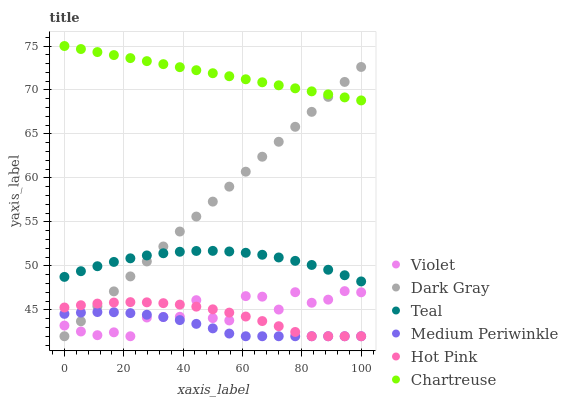Does Medium Periwinkle have the minimum area under the curve?
Answer yes or no. Yes. Does Chartreuse have the maximum area under the curve?
Answer yes or no. Yes. Does Dark Gray have the minimum area under the curve?
Answer yes or no. No. Does Dark Gray have the maximum area under the curve?
Answer yes or no. No. Is Dark Gray the smoothest?
Answer yes or no. Yes. Is Violet the roughest?
Answer yes or no. Yes. Is Medium Periwinkle the smoothest?
Answer yes or no. No. Is Medium Periwinkle the roughest?
Answer yes or no. No. Does Hot Pink have the lowest value?
Answer yes or no. Yes. Does Chartreuse have the lowest value?
Answer yes or no. No. Does Chartreuse have the highest value?
Answer yes or no. Yes. Does Dark Gray have the highest value?
Answer yes or no. No. Is Violet less than Chartreuse?
Answer yes or no. Yes. Is Chartreuse greater than Violet?
Answer yes or no. Yes. Does Hot Pink intersect Dark Gray?
Answer yes or no. Yes. Is Hot Pink less than Dark Gray?
Answer yes or no. No. Is Hot Pink greater than Dark Gray?
Answer yes or no. No. Does Violet intersect Chartreuse?
Answer yes or no. No. 